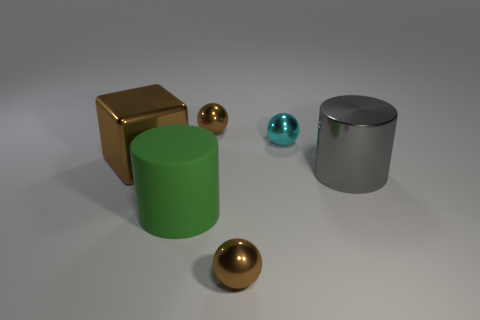Add 3 green cylinders. How many objects exist? 9 Subtract all blocks. How many objects are left? 5 Subtract 0 red spheres. How many objects are left? 6 Subtract all brown metallic things. Subtract all shiny spheres. How many objects are left? 0 Add 3 large objects. How many large objects are left? 6 Add 3 large gray cylinders. How many large gray cylinders exist? 4 